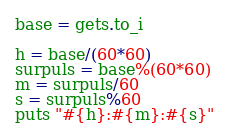<code> <loc_0><loc_0><loc_500><loc_500><_Ruby_>base = gets.to_i

h = base/(60*60)
surpuls = base%(60*60)
m = surpuls/60
s = surpuls%60
puts "#{h}:#{m}:#{s}" </code> 